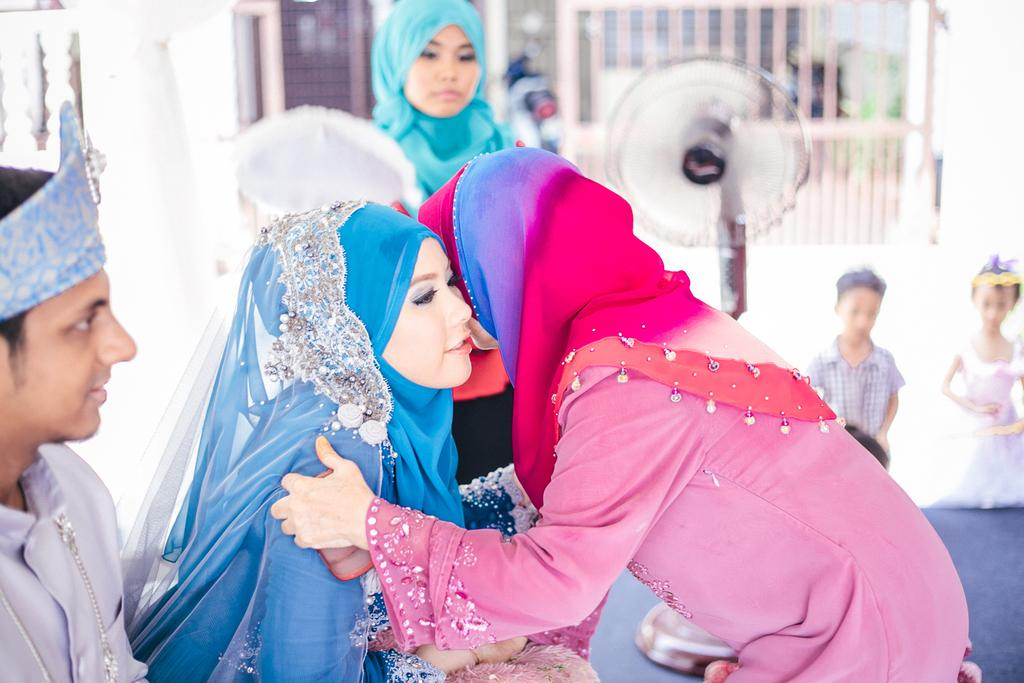How many people are visible in the image? There are two ladies in the image. What might the ladies be doing in the image? The ladies may be greeting each other. Can you describe the background of the image? There is a girl and two kids in the background of the image, along with a blurred fan. What type of clouds can be seen in the image? There are no clouds visible in the image. What letters are present on the ladies' clothing in the image? There is no information about letters on the ladies' clothing in the image. 